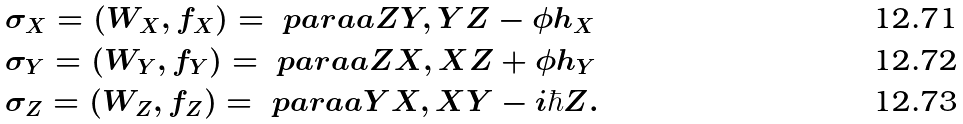<formula> <loc_0><loc_0><loc_500><loc_500>& \sigma _ { X } = ( W _ { X } , f _ { X } ) = \ p a r a a { Z Y , Y Z - \phi h _ { X } } \\ & \sigma _ { Y } = ( W _ { Y } , f _ { Y } ) = \ p a r a a { Z X , X Z + \phi h _ { Y } } \\ & \sigma _ { Z } = ( W _ { Z } , f _ { Z } ) = \ p a r a a { Y X , X Y - i \hbar { Z } } .</formula> 